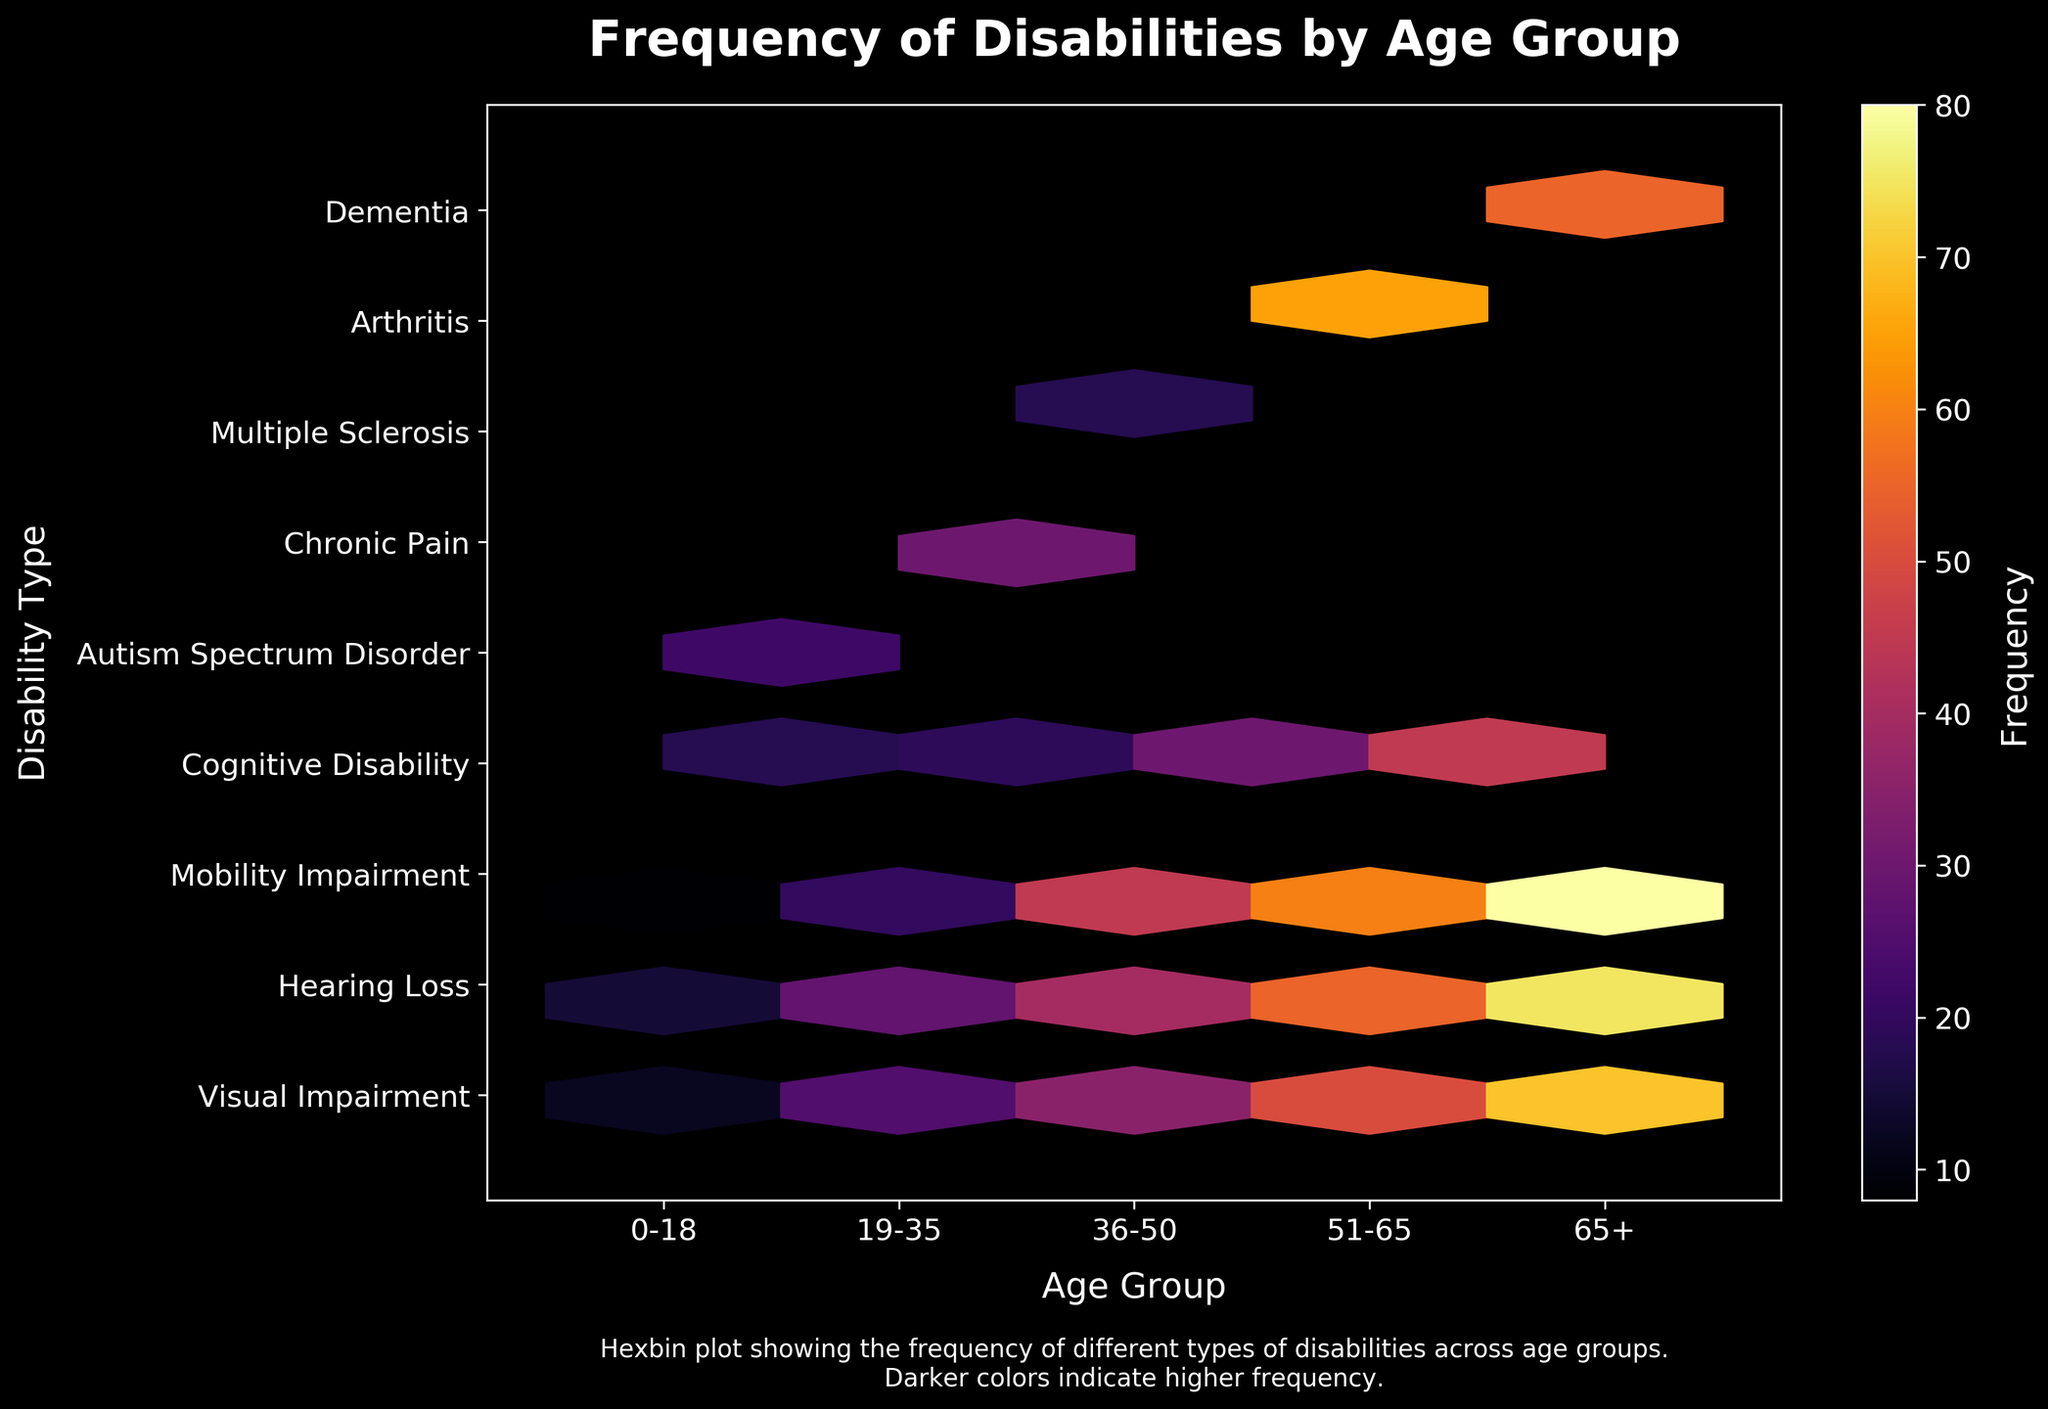What is the main title of the plot? The main title is usually found at the top of the plot. In this case, it reads "Frequency of Disabilities by Age Group".
Answer: Frequency of Disabilities by Age Group Which age group shows the highest frequency of mobility impairment? To determine this, look at the colors on the hexagons corresponding to Mobility Impairment on the y-axis and compare the shades of color for each age group. The darker the color, the higher the frequency.
Answer: 65+ Which type of disability has the highest frequency in the age group 36-50? Examine the hexagons corresponding to the age group 36-50 on the x-axis and see which hexagon has the darkest color. Mobility Impairment has the darkest shade.
Answer: Mobility Impairment How does the frequency of visual impairment change across age groups? To identify the change, look at the color shade of hexagons corresponding to Visual Impairment in each age group from 0-18 to 65+. The shade gets progressively darker, indicating increasing frequency.
Answer: Increases Which age group has the lowest frequency of cognitive disability? Compare the shades of hexagons corresponding to Cognitive Disability across all age groups. The lightest shade represents the lowest frequency.
Answer: 0-18 What is the difference in frequency of hearing loss between the age groups 0-18 and 51-65? Identify the shades of the hexagons for Hearing Loss in these age groups and refer to the color bar to convert these to frequency values. Then, subtract the smaller frequency from the larger one.
Answer: 55 - 15 = 40 Which disability sees a significant increase in frequency from the age group 19-35 to 36-50? Compare the shades of colors for each disability in these two age groups. Look for a noticeable change towards a darker shade in the latter group. Mobility Impairment shows this significant increase.
Answer: Mobility Impairment Is the frequency of chronic pain greater than that of multiple sclerosis in the 19-35 age group? Check the color shades of the hexagons for Chronic Pain and Multiple Sclerosis within the 19-35 age group. Compare them according to the color bar scale. Chronic Pain has a darker shade.
Answer: Yes Does the age group 65+ have the highest frequency for any types of disabilities? Look at the hexagons in the age group 65+ and identify if any of them are the darkest when compared to the corresponding hexagons in other age groups. Visual Impairment and Mobility Impairment have the darkest hexagons in this group.
Answer: Yes What is the sum of frequencies for visual impairment across all age groups? Adding these frequencies involves identifying the corresponding shades for Visual Impairment in each age group and summing them up based on the color bar values: 12 (0-18) + 25 (19-35) + 35 (36-50) + 50 (51-65) + 70 (65+).
Answer: 192 